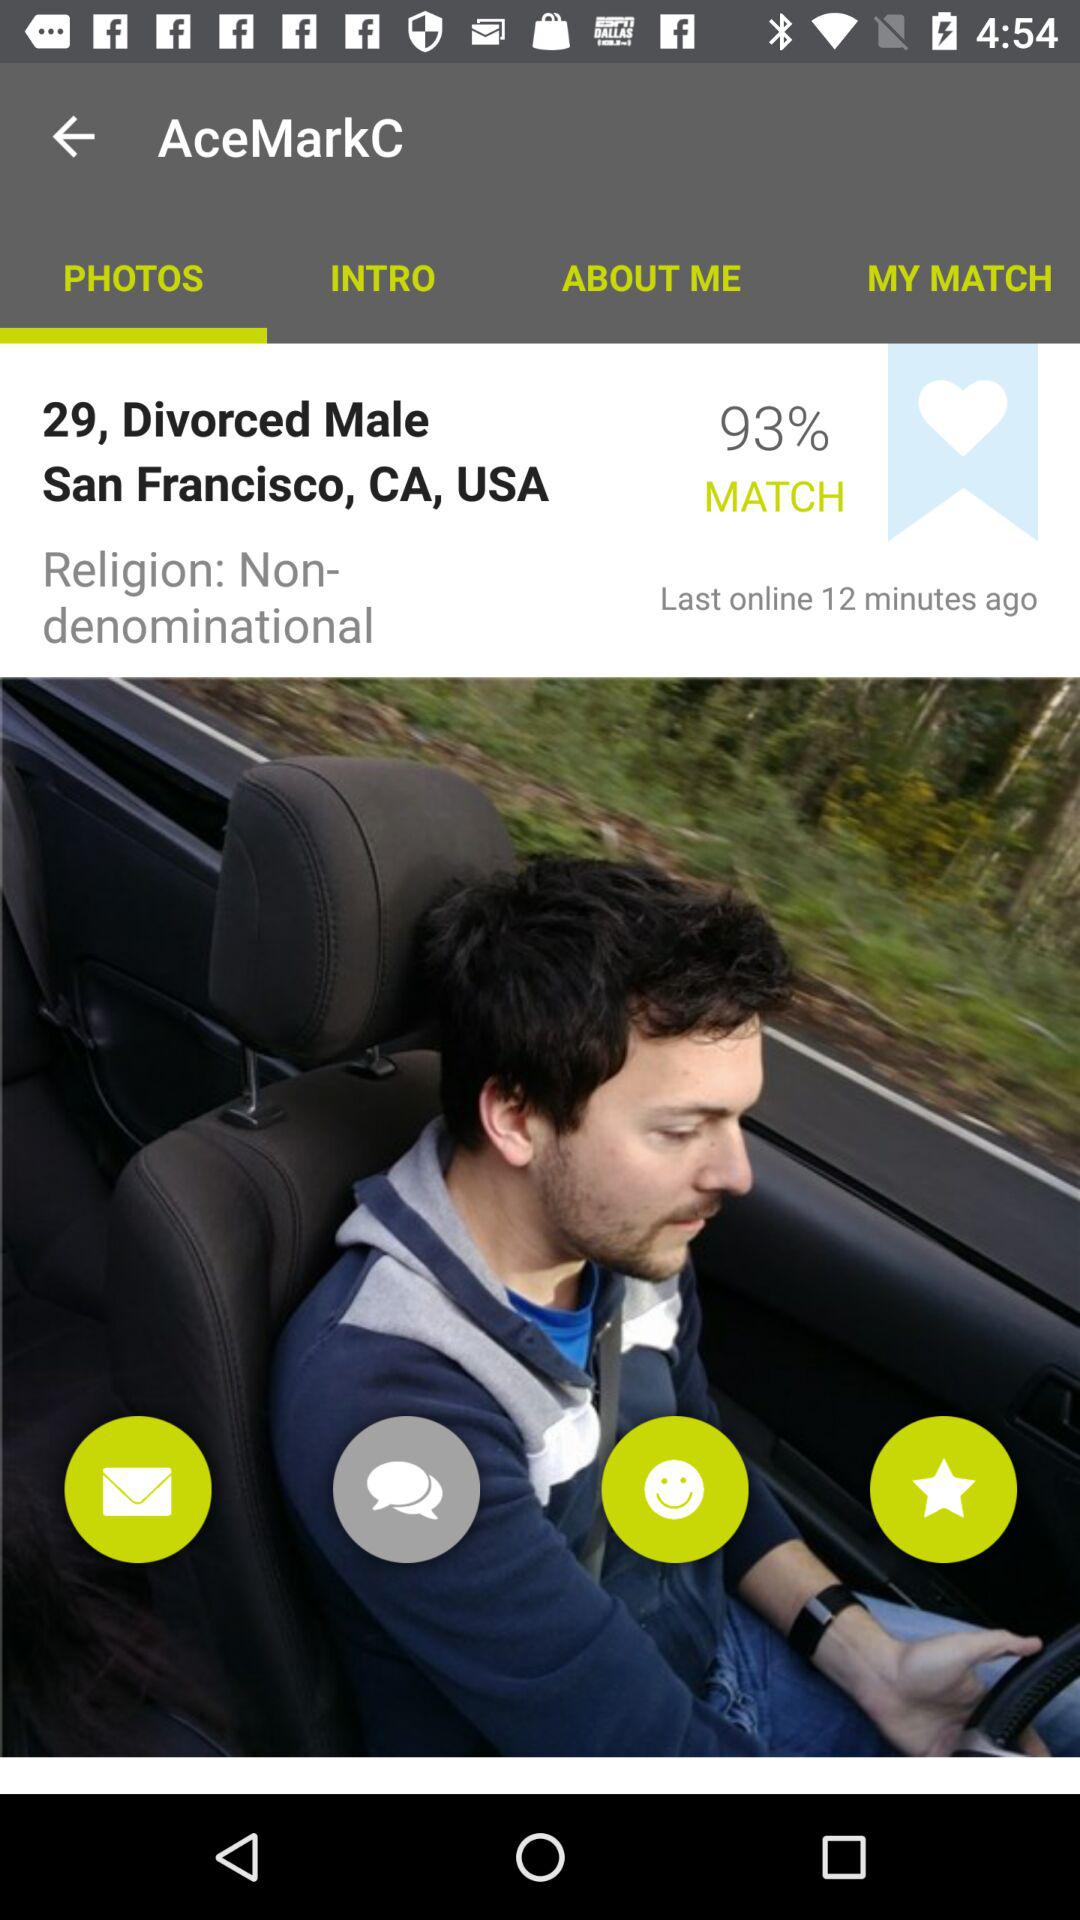When was AceMarkC last online? AceMarkC was online 12 minutes ago. 